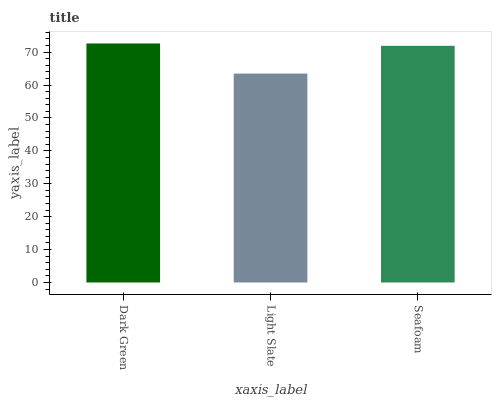Is Light Slate the minimum?
Answer yes or no. Yes. Is Dark Green the maximum?
Answer yes or no. Yes. Is Seafoam the minimum?
Answer yes or no. No. Is Seafoam the maximum?
Answer yes or no. No. Is Seafoam greater than Light Slate?
Answer yes or no. Yes. Is Light Slate less than Seafoam?
Answer yes or no. Yes. Is Light Slate greater than Seafoam?
Answer yes or no. No. Is Seafoam less than Light Slate?
Answer yes or no. No. Is Seafoam the high median?
Answer yes or no. Yes. Is Seafoam the low median?
Answer yes or no. Yes. Is Dark Green the high median?
Answer yes or no. No. Is Dark Green the low median?
Answer yes or no. No. 